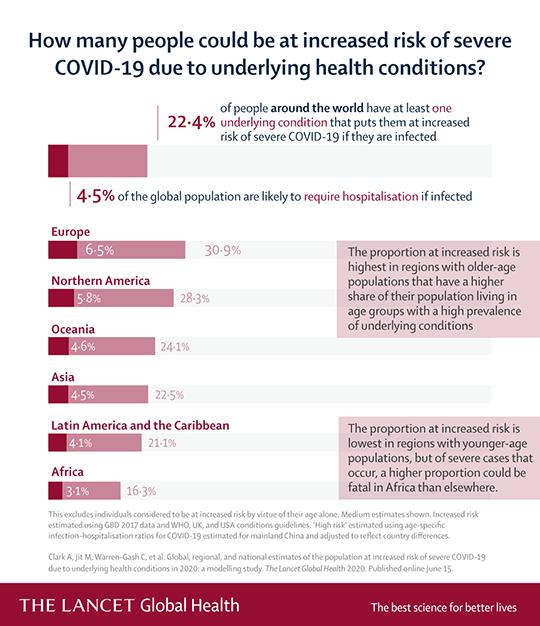Identify some key points in this picture. Approximately 95.5% of the global population who are infected with COVID-19 are not likely to require hospitalization. 